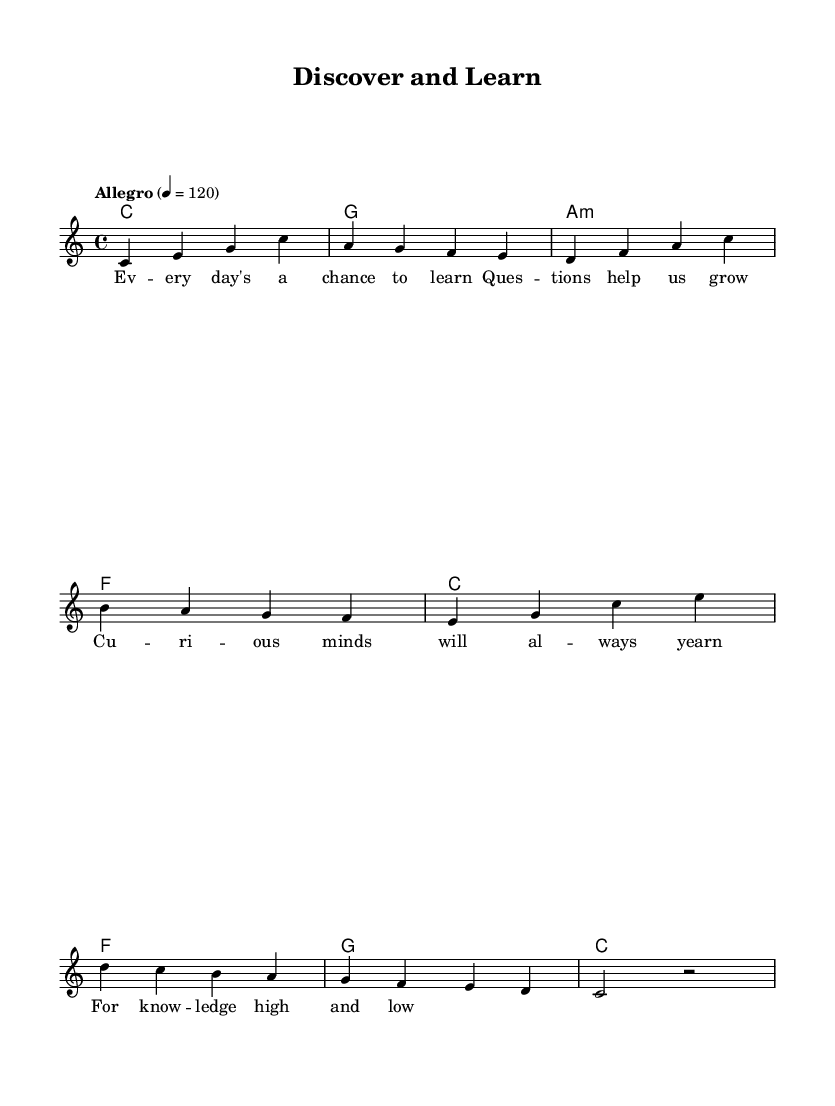What is the key signature of this music? The key signature is indicated at the beginning of the staff and shows no sharps or flats, meaning it is C major.
Answer: C major What is the time signature of this piece? The time signature is located at the beginning of the music and is displayed as 4/4, indicating four beats per measure with a quarter note receiving one beat.
Answer: 4/4 What tempo marking is given in the music? The tempo marking, located above the staff, indicates the speed of the piece as "Allegro" with a metronome mark of 120 beats per minute.
Answer: Allegro 4 = 120 How many measures are there in the melody? By counting each group of notes and rests separated by vertical lines (bar lines), there are a total of 8 measures in the melody.
Answer: 8 What is the main theme of the lyrics? The lyrics convey the idea of curiosity and the importance of asking questions to learn, which is reflected in phrases like "Every day's a chance to learn."
Answer: Curiosity and learning What is the first note of the melody? The first note in the melody is the note C, which can be identified at the start of the sequence, showing the starting pitch of the song.
Answer: C What type of chords are used in the harmony part? The harmony part contains a mix of major and minor chords, specifically C major, G major, A minor, and F major, representing typical triad structures in pop music.
Answer: Major and minor chords 